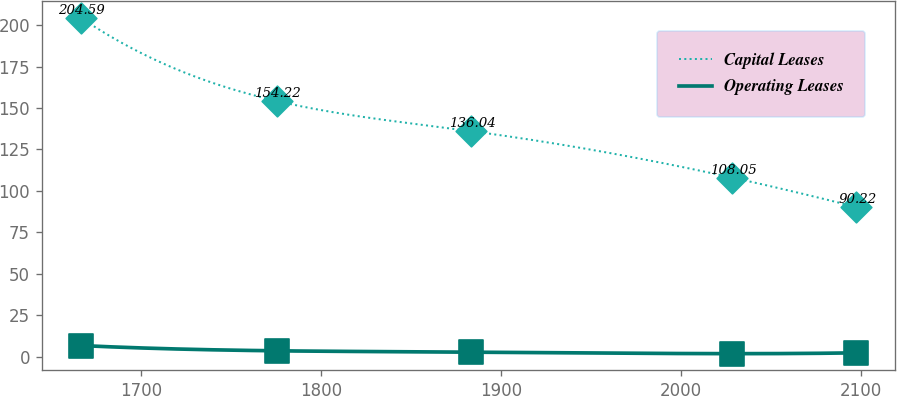<chart> <loc_0><loc_0><loc_500><loc_500><line_chart><ecel><fcel>Capital Leases<fcel>Operating Leases<nl><fcel>1666.29<fcel>204.59<fcel>6.68<nl><fcel>1775.5<fcel>154.22<fcel>3.5<nl><fcel>1883.61<fcel>136.04<fcel>2.76<nl><fcel>2028.56<fcel>108.05<fcel>1.78<nl><fcel>2097.74<fcel>90.22<fcel>2.27<nl></chart> 